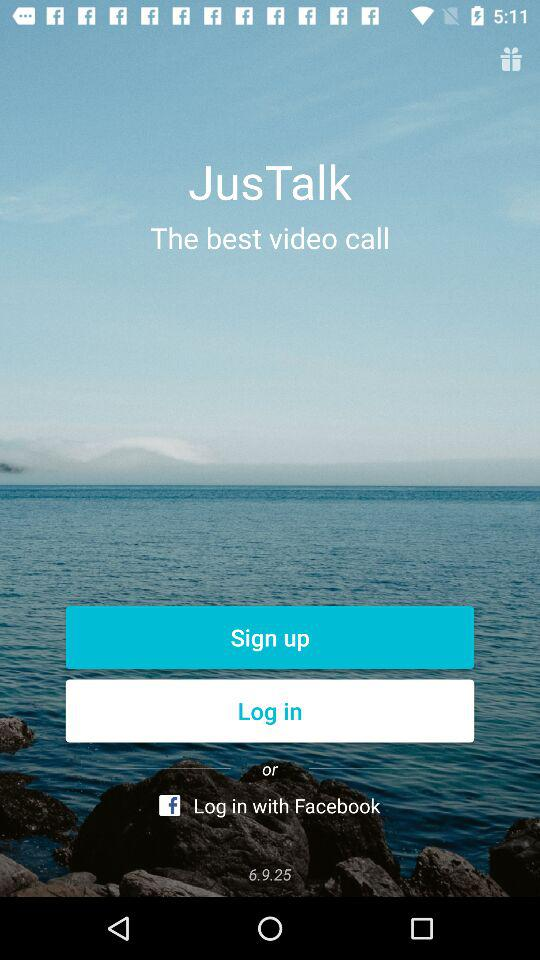What is the application name? The application name is "JusTalk". 